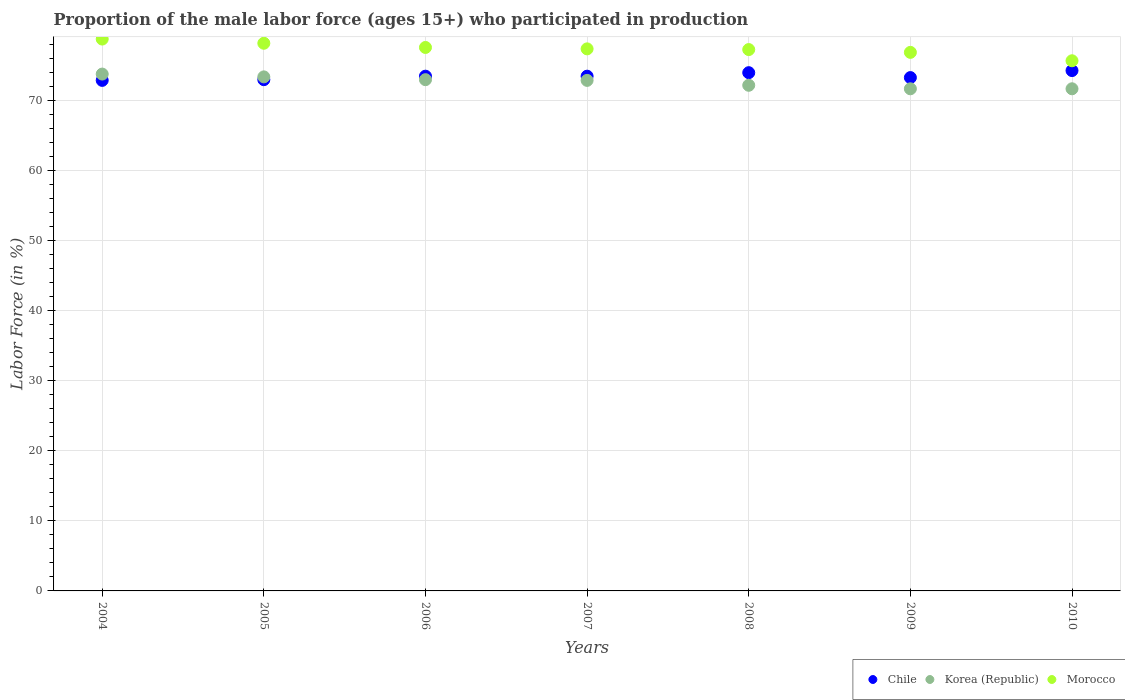How many different coloured dotlines are there?
Provide a short and direct response. 3. Is the number of dotlines equal to the number of legend labels?
Your answer should be very brief. Yes. What is the proportion of the male labor force who participated in production in Korea (Republic) in 2007?
Your answer should be very brief. 72.9. Across all years, what is the maximum proportion of the male labor force who participated in production in Morocco?
Provide a short and direct response. 78.8. Across all years, what is the minimum proportion of the male labor force who participated in production in Korea (Republic)?
Give a very brief answer. 71.7. In which year was the proportion of the male labor force who participated in production in Korea (Republic) maximum?
Offer a terse response. 2004. In which year was the proportion of the male labor force who participated in production in Chile minimum?
Keep it short and to the point. 2004. What is the total proportion of the male labor force who participated in production in Korea (Republic) in the graph?
Your response must be concise. 508.7. What is the difference between the proportion of the male labor force who participated in production in Chile in 2004 and that in 2009?
Ensure brevity in your answer.  -0.4. What is the difference between the proportion of the male labor force who participated in production in Korea (Republic) in 2009 and the proportion of the male labor force who participated in production in Chile in 2008?
Offer a terse response. -2.3. What is the average proportion of the male labor force who participated in production in Chile per year?
Ensure brevity in your answer.  73.5. In the year 2004, what is the difference between the proportion of the male labor force who participated in production in Morocco and proportion of the male labor force who participated in production in Korea (Republic)?
Offer a terse response. 5. What is the ratio of the proportion of the male labor force who participated in production in Korea (Republic) in 2005 to that in 2006?
Your answer should be compact. 1.01. Is the proportion of the male labor force who participated in production in Chile in 2008 less than that in 2009?
Offer a very short reply. No. Is the difference between the proportion of the male labor force who participated in production in Morocco in 2007 and 2008 greater than the difference between the proportion of the male labor force who participated in production in Korea (Republic) in 2007 and 2008?
Give a very brief answer. No. What is the difference between the highest and the second highest proportion of the male labor force who participated in production in Chile?
Make the answer very short. 0.3. What is the difference between the highest and the lowest proportion of the male labor force who participated in production in Korea (Republic)?
Your response must be concise. 2.1. In how many years, is the proportion of the male labor force who participated in production in Korea (Republic) greater than the average proportion of the male labor force who participated in production in Korea (Republic) taken over all years?
Your answer should be compact. 4. Is the sum of the proportion of the male labor force who participated in production in Chile in 2005 and 2008 greater than the maximum proportion of the male labor force who participated in production in Korea (Republic) across all years?
Provide a short and direct response. Yes. Is it the case that in every year, the sum of the proportion of the male labor force who participated in production in Morocco and proportion of the male labor force who participated in production in Korea (Republic)  is greater than the proportion of the male labor force who participated in production in Chile?
Provide a short and direct response. Yes. Is the proportion of the male labor force who participated in production in Korea (Republic) strictly greater than the proportion of the male labor force who participated in production in Morocco over the years?
Make the answer very short. No. Is the proportion of the male labor force who participated in production in Korea (Republic) strictly less than the proportion of the male labor force who participated in production in Chile over the years?
Your answer should be compact. No. What is the difference between two consecutive major ticks on the Y-axis?
Ensure brevity in your answer.  10. Does the graph contain any zero values?
Provide a short and direct response. No. Does the graph contain grids?
Your answer should be compact. Yes. How many legend labels are there?
Your answer should be very brief. 3. What is the title of the graph?
Your response must be concise. Proportion of the male labor force (ages 15+) who participated in production. What is the label or title of the Y-axis?
Provide a succinct answer. Labor Force (in %). What is the Labor Force (in %) in Chile in 2004?
Give a very brief answer. 72.9. What is the Labor Force (in %) of Korea (Republic) in 2004?
Provide a succinct answer. 73.8. What is the Labor Force (in %) in Morocco in 2004?
Offer a terse response. 78.8. What is the Labor Force (in %) in Korea (Republic) in 2005?
Provide a succinct answer. 73.4. What is the Labor Force (in %) of Morocco in 2005?
Give a very brief answer. 78.2. What is the Labor Force (in %) in Chile in 2006?
Keep it short and to the point. 73.5. What is the Labor Force (in %) in Morocco in 2006?
Ensure brevity in your answer.  77.6. What is the Labor Force (in %) in Chile in 2007?
Give a very brief answer. 73.5. What is the Labor Force (in %) in Korea (Republic) in 2007?
Your answer should be very brief. 72.9. What is the Labor Force (in %) in Morocco in 2007?
Offer a terse response. 77.4. What is the Labor Force (in %) in Korea (Republic) in 2008?
Provide a succinct answer. 72.2. What is the Labor Force (in %) in Morocco in 2008?
Provide a short and direct response. 77.3. What is the Labor Force (in %) of Chile in 2009?
Ensure brevity in your answer.  73.3. What is the Labor Force (in %) of Korea (Republic) in 2009?
Provide a succinct answer. 71.7. What is the Labor Force (in %) of Morocco in 2009?
Offer a very short reply. 76.9. What is the Labor Force (in %) of Chile in 2010?
Your answer should be compact. 74.3. What is the Labor Force (in %) in Korea (Republic) in 2010?
Your answer should be very brief. 71.7. What is the Labor Force (in %) in Morocco in 2010?
Ensure brevity in your answer.  75.7. Across all years, what is the maximum Labor Force (in %) of Chile?
Offer a very short reply. 74.3. Across all years, what is the maximum Labor Force (in %) of Korea (Republic)?
Make the answer very short. 73.8. Across all years, what is the maximum Labor Force (in %) in Morocco?
Your answer should be compact. 78.8. Across all years, what is the minimum Labor Force (in %) of Chile?
Keep it short and to the point. 72.9. Across all years, what is the minimum Labor Force (in %) in Korea (Republic)?
Your response must be concise. 71.7. Across all years, what is the minimum Labor Force (in %) of Morocco?
Ensure brevity in your answer.  75.7. What is the total Labor Force (in %) in Chile in the graph?
Provide a succinct answer. 514.5. What is the total Labor Force (in %) of Korea (Republic) in the graph?
Give a very brief answer. 508.7. What is the total Labor Force (in %) in Morocco in the graph?
Ensure brevity in your answer.  541.9. What is the difference between the Labor Force (in %) of Chile in 2004 and that in 2005?
Make the answer very short. -0.1. What is the difference between the Labor Force (in %) of Korea (Republic) in 2004 and that in 2005?
Your response must be concise. 0.4. What is the difference between the Labor Force (in %) in Morocco in 2004 and that in 2006?
Make the answer very short. 1.2. What is the difference between the Labor Force (in %) in Chile in 2004 and that in 2007?
Your answer should be compact. -0.6. What is the difference between the Labor Force (in %) in Korea (Republic) in 2004 and that in 2008?
Provide a succinct answer. 1.6. What is the difference between the Labor Force (in %) in Chile in 2004 and that in 2010?
Offer a terse response. -1.4. What is the difference between the Labor Force (in %) in Morocco in 2004 and that in 2010?
Give a very brief answer. 3.1. What is the difference between the Labor Force (in %) of Morocco in 2005 and that in 2007?
Make the answer very short. 0.8. What is the difference between the Labor Force (in %) in Korea (Republic) in 2005 and that in 2008?
Offer a terse response. 1.2. What is the difference between the Labor Force (in %) of Morocco in 2005 and that in 2009?
Your answer should be very brief. 1.3. What is the difference between the Labor Force (in %) of Korea (Republic) in 2005 and that in 2010?
Your answer should be very brief. 1.7. What is the difference between the Labor Force (in %) of Morocco in 2005 and that in 2010?
Offer a very short reply. 2.5. What is the difference between the Labor Force (in %) of Korea (Republic) in 2006 and that in 2007?
Provide a short and direct response. 0.1. What is the difference between the Labor Force (in %) of Chile in 2006 and that in 2008?
Offer a terse response. -0.5. What is the difference between the Labor Force (in %) in Korea (Republic) in 2006 and that in 2008?
Give a very brief answer. 0.8. What is the difference between the Labor Force (in %) in Korea (Republic) in 2006 and that in 2009?
Your answer should be compact. 1.3. What is the difference between the Labor Force (in %) in Chile in 2006 and that in 2010?
Offer a terse response. -0.8. What is the difference between the Labor Force (in %) in Chile in 2007 and that in 2008?
Offer a very short reply. -0.5. What is the difference between the Labor Force (in %) of Korea (Republic) in 2007 and that in 2008?
Offer a very short reply. 0.7. What is the difference between the Labor Force (in %) of Chile in 2007 and that in 2009?
Provide a short and direct response. 0.2. What is the difference between the Labor Force (in %) in Korea (Republic) in 2007 and that in 2009?
Provide a succinct answer. 1.2. What is the difference between the Labor Force (in %) in Morocco in 2007 and that in 2009?
Offer a very short reply. 0.5. What is the difference between the Labor Force (in %) of Chile in 2007 and that in 2010?
Offer a terse response. -0.8. What is the difference between the Labor Force (in %) in Chile in 2008 and that in 2009?
Make the answer very short. 0.7. What is the difference between the Labor Force (in %) in Morocco in 2008 and that in 2010?
Provide a succinct answer. 1.6. What is the difference between the Labor Force (in %) of Chile in 2009 and that in 2010?
Ensure brevity in your answer.  -1. What is the difference between the Labor Force (in %) in Korea (Republic) in 2009 and that in 2010?
Ensure brevity in your answer.  0. What is the difference between the Labor Force (in %) in Morocco in 2009 and that in 2010?
Give a very brief answer. 1.2. What is the difference between the Labor Force (in %) of Chile in 2004 and the Labor Force (in %) of Korea (Republic) in 2005?
Provide a short and direct response. -0.5. What is the difference between the Labor Force (in %) of Chile in 2004 and the Labor Force (in %) of Korea (Republic) in 2006?
Make the answer very short. -0.1. What is the difference between the Labor Force (in %) in Chile in 2004 and the Labor Force (in %) in Korea (Republic) in 2007?
Provide a succinct answer. 0. What is the difference between the Labor Force (in %) of Korea (Republic) in 2004 and the Labor Force (in %) of Morocco in 2007?
Keep it short and to the point. -3.6. What is the difference between the Labor Force (in %) of Chile in 2004 and the Labor Force (in %) of Morocco in 2009?
Ensure brevity in your answer.  -4. What is the difference between the Labor Force (in %) in Chile in 2004 and the Labor Force (in %) in Korea (Republic) in 2010?
Offer a terse response. 1.2. What is the difference between the Labor Force (in %) in Korea (Republic) in 2004 and the Labor Force (in %) in Morocco in 2010?
Your answer should be very brief. -1.9. What is the difference between the Labor Force (in %) of Chile in 2005 and the Labor Force (in %) of Korea (Republic) in 2006?
Provide a short and direct response. 0. What is the difference between the Labor Force (in %) of Chile in 2005 and the Labor Force (in %) of Morocco in 2006?
Keep it short and to the point. -4.6. What is the difference between the Labor Force (in %) of Chile in 2005 and the Labor Force (in %) of Morocco in 2007?
Make the answer very short. -4.4. What is the difference between the Labor Force (in %) of Korea (Republic) in 2005 and the Labor Force (in %) of Morocco in 2008?
Provide a succinct answer. -3.9. What is the difference between the Labor Force (in %) in Korea (Republic) in 2005 and the Labor Force (in %) in Morocco in 2009?
Provide a short and direct response. -3.5. What is the difference between the Labor Force (in %) in Chile in 2005 and the Labor Force (in %) in Korea (Republic) in 2010?
Give a very brief answer. 1.3. What is the difference between the Labor Force (in %) of Chile in 2006 and the Labor Force (in %) of Korea (Republic) in 2007?
Keep it short and to the point. 0.6. What is the difference between the Labor Force (in %) of Chile in 2006 and the Labor Force (in %) of Morocco in 2007?
Your answer should be compact. -3.9. What is the difference between the Labor Force (in %) in Chile in 2006 and the Labor Force (in %) in Korea (Republic) in 2008?
Your answer should be compact. 1.3. What is the difference between the Labor Force (in %) of Chile in 2006 and the Labor Force (in %) of Morocco in 2009?
Ensure brevity in your answer.  -3.4. What is the difference between the Labor Force (in %) of Korea (Republic) in 2006 and the Labor Force (in %) of Morocco in 2010?
Ensure brevity in your answer.  -2.7. What is the difference between the Labor Force (in %) in Chile in 2007 and the Labor Force (in %) in Korea (Republic) in 2008?
Make the answer very short. 1.3. What is the difference between the Labor Force (in %) in Chile in 2007 and the Labor Force (in %) in Morocco in 2008?
Your response must be concise. -3.8. What is the difference between the Labor Force (in %) in Korea (Republic) in 2007 and the Labor Force (in %) in Morocco in 2008?
Make the answer very short. -4.4. What is the difference between the Labor Force (in %) of Chile in 2007 and the Labor Force (in %) of Korea (Republic) in 2009?
Offer a terse response. 1.8. What is the difference between the Labor Force (in %) of Korea (Republic) in 2007 and the Labor Force (in %) of Morocco in 2009?
Your answer should be compact. -4. What is the difference between the Labor Force (in %) of Chile in 2007 and the Labor Force (in %) of Morocco in 2010?
Give a very brief answer. -2.2. What is the difference between the Labor Force (in %) in Korea (Republic) in 2008 and the Labor Force (in %) in Morocco in 2009?
Make the answer very short. -4.7. What is the difference between the Labor Force (in %) of Chile in 2008 and the Labor Force (in %) of Korea (Republic) in 2010?
Ensure brevity in your answer.  2.3. What is the difference between the Labor Force (in %) of Chile in 2008 and the Labor Force (in %) of Morocco in 2010?
Your answer should be compact. -1.7. What is the average Labor Force (in %) in Chile per year?
Your response must be concise. 73.5. What is the average Labor Force (in %) in Korea (Republic) per year?
Keep it short and to the point. 72.67. What is the average Labor Force (in %) of Morocco per year?
Make the answer very short. 77.41. In the year 2004, what is the difference between the Labor Force (in %) in Korea (Republic) and Labor Force (in %) in Morocco?
Your answer should be very brief. -5. In the year 2006, what is the difference between the Labor Force (in %) in Chile and Labor Force (in %) in Morocco?
Your answer should be very brief. -4.1. In the year 2008, what is the difference between the Labor Force (in %) in Chile and Labor Force (in %) in Korea (Republic)?
Provide a short and direct response. 1.8. In the year 2009, what is the difference between the Labor Force (in %) in Chile and Labor Force (in %) in Korea (Republic)?
Make the answer very short. 1.6. In the year 2009, what is the difference between the Labor Force (in %) of Chile and Labor Force (in %) of Morocco?
Keep it short and to the point. -3.6. What is the ratio of the Labor Force (in %) of Chile in 2004 to that in 2005?
Your response must be concise. 1. What is the ratio of the Labor Force (in %) of Korea (Republic) in 2004 to that in 2005?
Your response must be concise. 1.01. What is the ratio of the Labor Force (in %) in Morocco in 2004 to that in 2005?
Your response must be concise. 1.01. What is the ratio of the Labor Force (in %) in Chile in 2004 to that in 2006?
Provide a succinct answer. 0.99. What is the ratio of the Labor Force (in %) in Morocco in 2004 to that in 2006?
Provide a short and direct response. 1.02. What is the ratio of the Labor Force (in %) of Chile in 2004 to that in 2007?
Ensure brevity in your answer.  0.99. What is the ratio of the Labor Force (in %) in Korea (Republic) in 2004 to that in 2007?
Offer a very short reply. 1.01. What is the ratio of the Labor Force (in %) of Morocco in 2004 to that in 2007?
Make the answer very short. 1.02. What is the ratio of the Labor Force (in %) in Chile in 2004 to that in 2008?
Provide a short and direct response. 0.99. What is the ratio of the Labor Force (in %) of Korea (Republic) in 2004 to that in 2008?
Keep it short and to the point. 1.02. What is the ratio of the Labor Force (in %) in Morocco in 2004 to that in 2008?
Ensure brevity in your answer.  1.02. What is the ratio of the Labor Force (in %) of Chile in 2004 to that in 2009?
Offer a very short reply. 0.99. What is the ratio of the Labor Force (in %) in Korea (Republic) in 2004 to that in 2009?
Make the answer very short. 1.03. What is the ratio of the Labor Force (in %) in Morocco in 2004 to that in 2009?
Keep it short and to the point. 1.02. What is the ratio of the Labor Force (in %) in Chile in 2004 to that in 2010?
Offer a terse response. 0.98. What is the ratio of the Labor Force (in %) in Korea (Republic) in 2004 to that in 2010?
Offer a very short reply. 1.03. What is the ratio of the Labor Force (in %) in Morocco in 2004 to that in 2010?
Provide a succinct answer. 1.04. What is the ratio of the Labor Force (in %) of Chile in 2005 to that in 2006?
Offer a terse response. 0.99. What is the ratio of the Labor Force (in %) of Morocco in 2005 to that in 2006?
Your response must be concise. 1.01. What is the ratio of the Labor Force (in %) of Korea (Republic) in 2005 to that in 2007?
Give a very brief answer. 1.01. What is the ratio of the Labor Force (in %) of Morocco in 2005 to that in 2007?
Your answer should be very brief. 1.01. What is the ratio of the Labor Force (in %) in Chile in 2005 to that in 2008?
Your answer should be very brief. 0.99. What is the ratio of the Labor Force (in %) of Korea (Republic) in 2005 to that in 2008?
Your answer should be very brief. 1.02. What is the ratio of the Labor Force (in %) in Morocco in 2005 to that in 2008?
Provide a succinct answer. 1.01. What is the ratio of the Labor Force (in %) of Chile in 2005 to that in 2009?
Ensure brevity in your answer.  1. What is the ratio of the Labor Force (in %) of Korea (Republic) in 2005 to that in 2009?
Provide a succinct answer. 1.02. What is the ratio of the Labor Force (in %) of Morocco in 2005 to that in 2009?
Provide a short and direct response. 1.02. What is the ratio of the Labor Force (in %) in Chile in 2005 to that in 2010?
Keep it short and to the point. 0.98. What is the ratio of the Labor Force (in %) in Korea (Republic) in 2005 to that in 2010?
Provide a short and direct response. 1.02. What is the ratio of the Labor Force (in %) of Morocco in 2005 to that in 2010?
Provide a short and direct response. 1.03. What is the ratio of the Labor Force (in %) in Chile in 2006 to that in 2007?
Ensure brevity in your answer.  1. What is the ratio of the Labor Force (in %) of Korea (Republic) in 2006 to that in 2007?
Provide a short and direct response. 1. What is the ratio of the Labor Force (in %) in Morocco in 2006 to that in 2007?
Your answer should be very brief. 1. What is the ratio of the Labor Force (in %) of Chile in 2006 to that in 2008?
Your response must be concise. 0.99. What is the ratio of the Labor Force (in %) of Korea (Republic) in 2006 to that in 2008?
Offer a terse response. 1.01. What is the ratio of the Labor Force (in %) in Chile in 2006 to that in 2009?
Make the answer very short. 1. What is the ratio of the Labor Force (in %) of Korea (Republic) in 2006 to that in 2009?
Offer a very short reply. 1.02. What is the ratio of the Labor Force (in %) in Morocco in 2006 to that in 2009?
Offer a very short reply. 1.01. What is the ratio of the Labor Force (in %) in Korea (Republic) in 2006 to that in 2010?
Provide a short and direct response. 1.02. What is the ratio of the Labor Force (in %) in Morocco in 2006 to that in 2010?
Keep it short and to the point. 1.03. What is the ratio of the Labor Force (in %) of Chile in 2007 to that in 2008?
Give a very brief answer. 0.99. What is the ratio of the Labor Force (in %) of Korea (Republic) in 2007 to that in 2008?
Your response must be concise. 1.01. What is the ratio of the Labor Force (in %) in Morocco in 2007 to that in 2008?
Provide a short and direct response. 1. What is the ratio of the Labor Force (in %) of Korea (Republic) in 2007 to that in 2009?
Keep it short and to the point. 1.02. What is the ratio of the Labor Force (in %) in Morocco in 2007 to that in 2009?
Provide a succinct answer. 1.01. What is the ratio of the Labor Force (in %) in Chile in 2007 to that in 2010?
Provide a succinct answer. 0.99. What is the ratio of the Labor Force (in %) in Korea (Republic) in 2007 to that in 2010?
Your answer should be compact. 1.02. What is the ratio of the Labor Force (in %) of Morocco in 2007 to that in 2010?
Provide a succinct answer. 1.02. What is the ratio of the Labor Force (in %) of Chile in 2008 to that in 2009?
Offer a very short reply. 1.01. What is the ratio of the Labor Force (in %) in Morocco in 2008 to that in 2009?
Provide a short and direct response. 1.01. What is the ratio of the Labor Force (in %) of Morocco in 2008 to that in 2010?
Offer a terse response. 1.02. What is the ratio of the Labor Force (in %) of Chile in 2009 to that in 2010?
Offer a very short reply. 0.99. What is the ratio of the Labor Force (in %) in Morocco in 2009 to that in 2010?
Ensure brevity in your answer.  1.02. What is the difference between the highest and the second highest Labor Force (in %) of Korea (Republic)?
Give a very brief answer. 0.4. What is the difference between the highest and the second highest Labor Force (in %) in Morocco?
Provide a succinct answer. 0.6. What is the difference between the highest and the lowest Labor Force (in %) in Chile?
Your answer should be compact. 1.4. What is the difference between the highest and the lowest Labor Force (in %) of Korea (Republic)?
Provide a succinct answer. 2.1. 